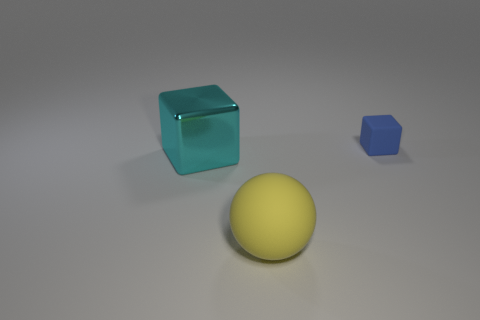Add 1 blue rubber things. How many objects exist? 4 Subtract all cyan cylinders. How many blue blocks are left? 1 Subtract all large cyan metallic cubes. Subtract all large rubber objects. How many objects are left? 1 Add 2 tiny matte objects. How many tiny matte objects are left? 3 Add 1 big yellow objects. How many big yellow objects exist? 2 Subtract 0 red spheres. How many objects are left? 3 Subtract all spheres. How many objects are left? 2 Subtract all purple balls. Subtract all yellow blocks. How many balls are left? 1 